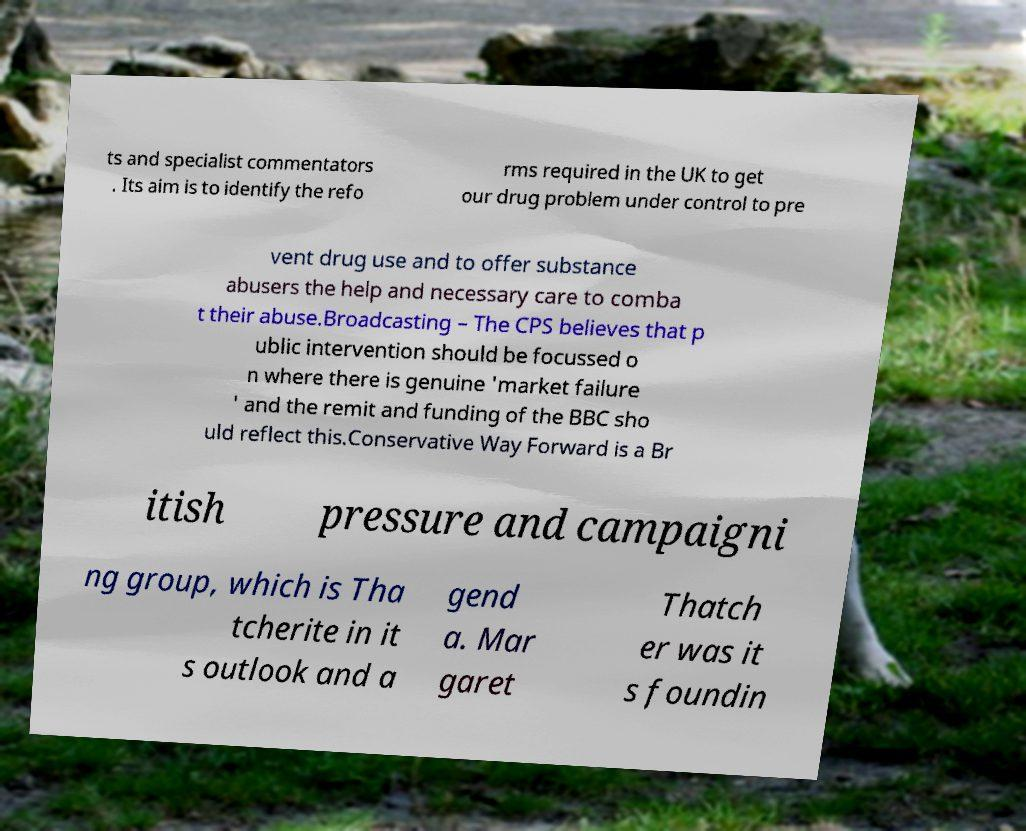For documentation purposes, I need the text within this image transcribed. Could you provide that? ts and specialist commentators . Its aim is to identify the refo rms required in the UK to get our drug problem under control to pre vent drug use and to offer substance abusers the help and necessary care to comba t their abuse.Broadcasting – The CPS believes that p ublic intervention should be focussed o n where there is genuine 'market failure ' and the remit and funding of the BBC sho uld reflect this.Conservative Way Forward is a Br itish pressure and campaigni ng group, which is Tha tcherite in it s outlook and a gend a. Mar garet Thatch er was it s foundin 